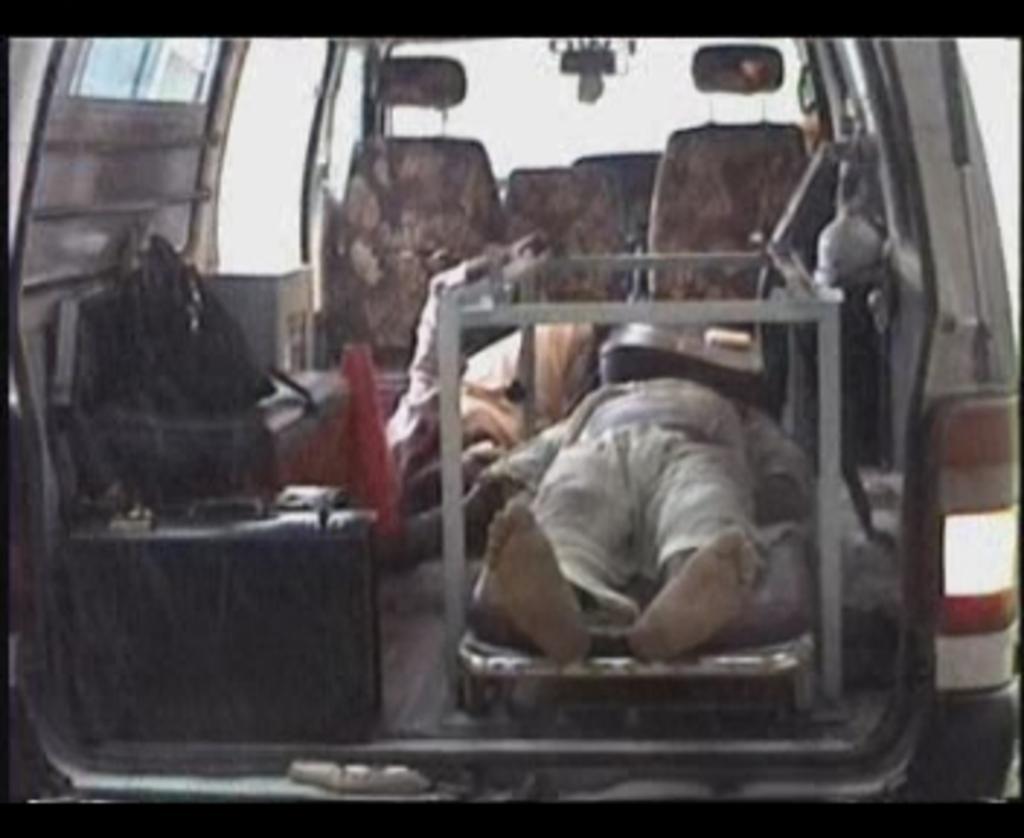In one or two sentences, can you explain what this image depicts? This is a vehicle. In this a person is lying on a stretcher. On the left side there is a bag on the seat. Also there is a suitcase. On the right side there is a light for the vehicle. In the back there are seats for the vehicle. 